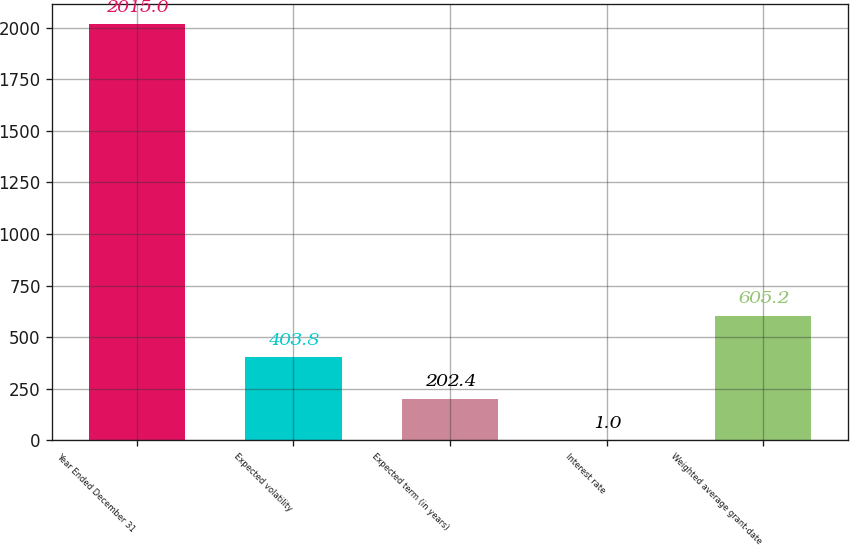Convert chart to OTSL. <chart><loc_0><loc_0><loc_500><loc_500><bar_chart><fcel>Year Ended December 31<fcel>Expected volatility<fcel>Expected term (in years)<fcel>Interest rate<fcel>Weighted average grant-date<nl><fcel>2015<fcel>403.8<fcel>202.4<fcel>1<fcel>605.2<nl></chart> 